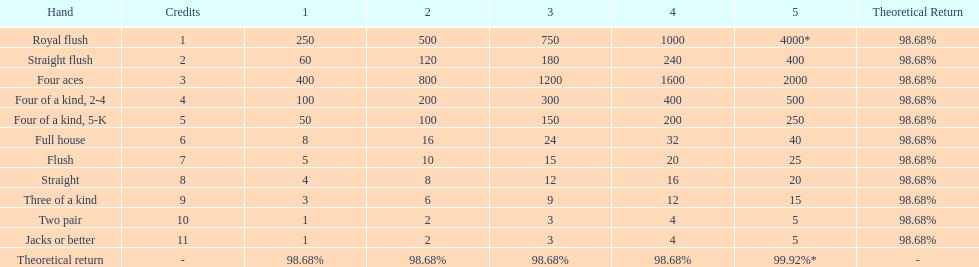The number of flush wins at one credit to equal one flush win at 5 credits. 5. Could you parse the entire table as a dict? {'header': ['Hand', 'Credits', '1', '2', '3', '4', '5', 'Theoretical Return'], 'rows': [['Royal flush', '1', '250', '500', '750', '1000', '4000*', '98.68%'], ['Straight flush', '2', '60', '120', '180', '240', '400', '98.68%'], ['Four aces', '3', '400', '800', '1200', '1600', '2000', '98.68%'], ['Four of a kind, 2-4', '4', '100', '200', '300', '400', '500', '98.68%'], ['Four of a kind, 5-K', '5', '50', '100', '150', '200', '250', '98.68%'], ['Full house', '6', '8', '16', '24', '32', '40', '98.68%'], ['Flush', '7', '5', '10', '15', '20', '25', '98.68%'], ['Straight', '8', '4', '8', '12', '16', '20', '98.68%'], ['Three of a kind', '9', '3', '6', '9', '12', '15', '98.68%'], ['Two pair', '10', '1', '2', '3', '4', '5', '98.68%'], ['Jacks or better', '11', '1', '2', '3', '4', '5', '98.68%'], ['Theoretical return', '-', '98.68%', '98.68%', '98.68%', '98.68%', '99.92%*', '-']]} 